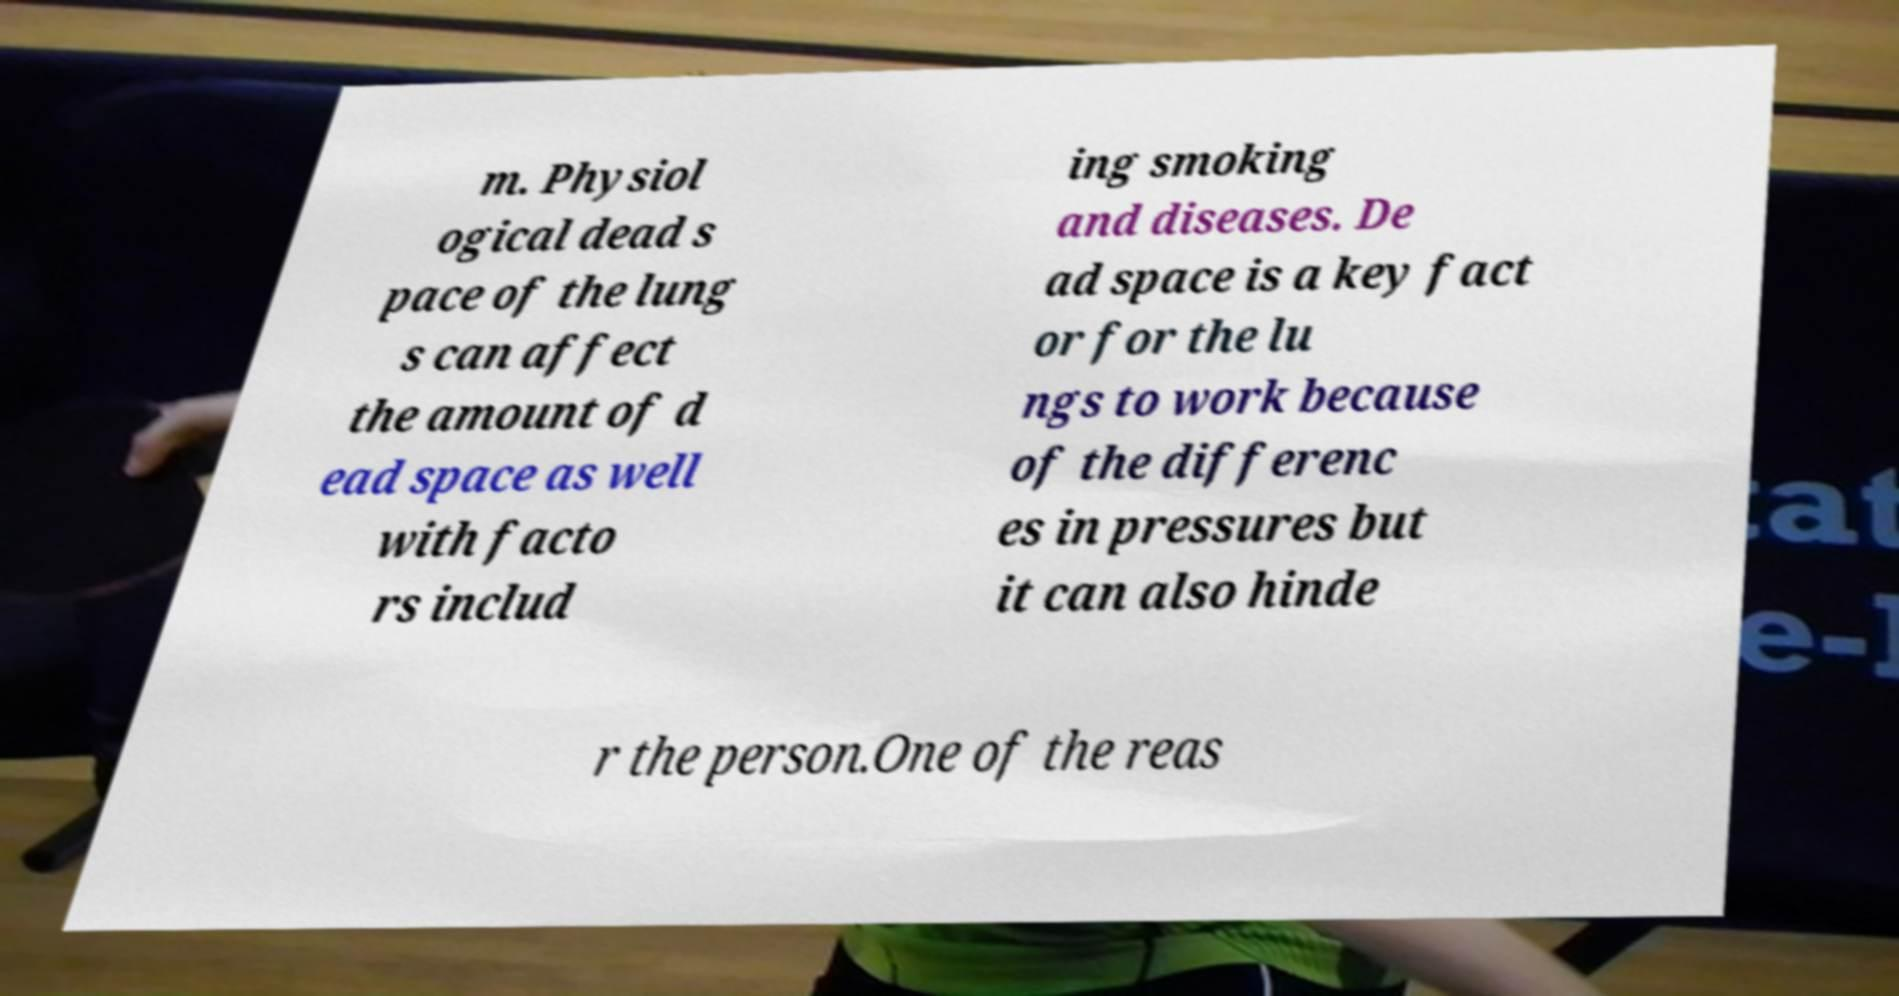Could you extract and type out the text from this image? m. Physiol ogical dead s pace of the lung s can affect the amount of d ead space as well with facto rs includ ing smoking and diseases. De ad space is a key fact or for the lu ngs to work because of the differenc es in pressures but it can also hinde r the person.One of the reas 